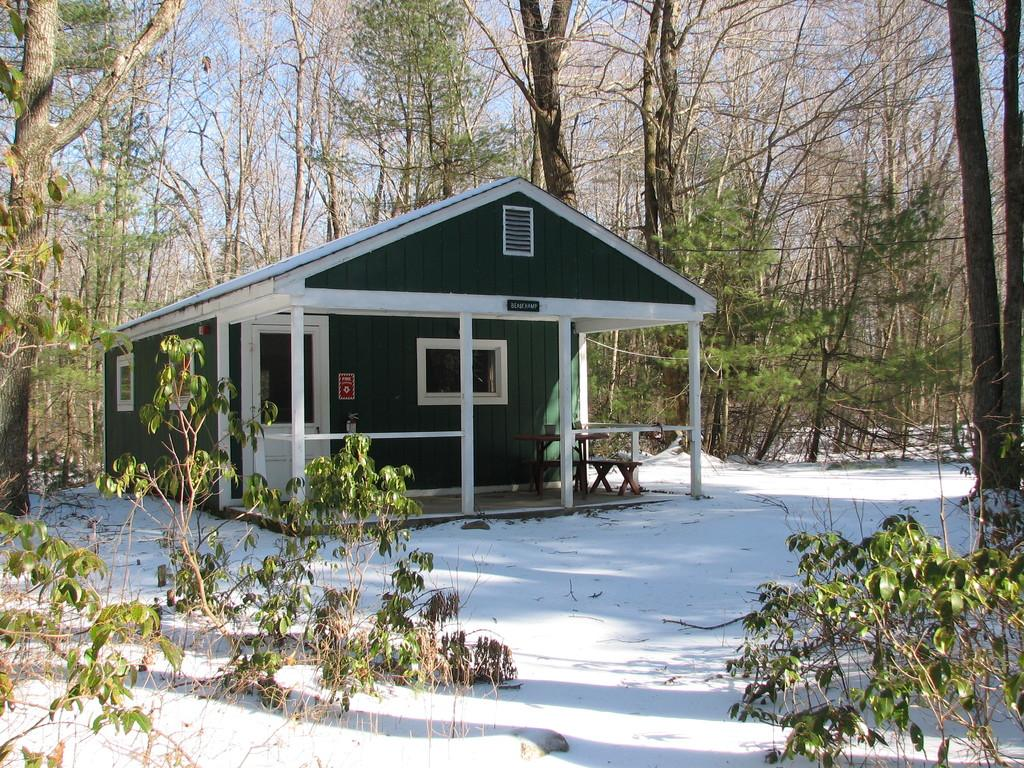What type of structure is visible in the image? There is a house in the image. What is covering the ground in front of the house? There is snow in front of the house. What type of vegetation is present in front of the house? There are plants in front of the house. What can be seen behind the house? There are trees behind the house. What is visible above the house? The sky is visible in the image. Where is the crate of plastic toys located in the image? There is no crate of plastic toys present in the image. 